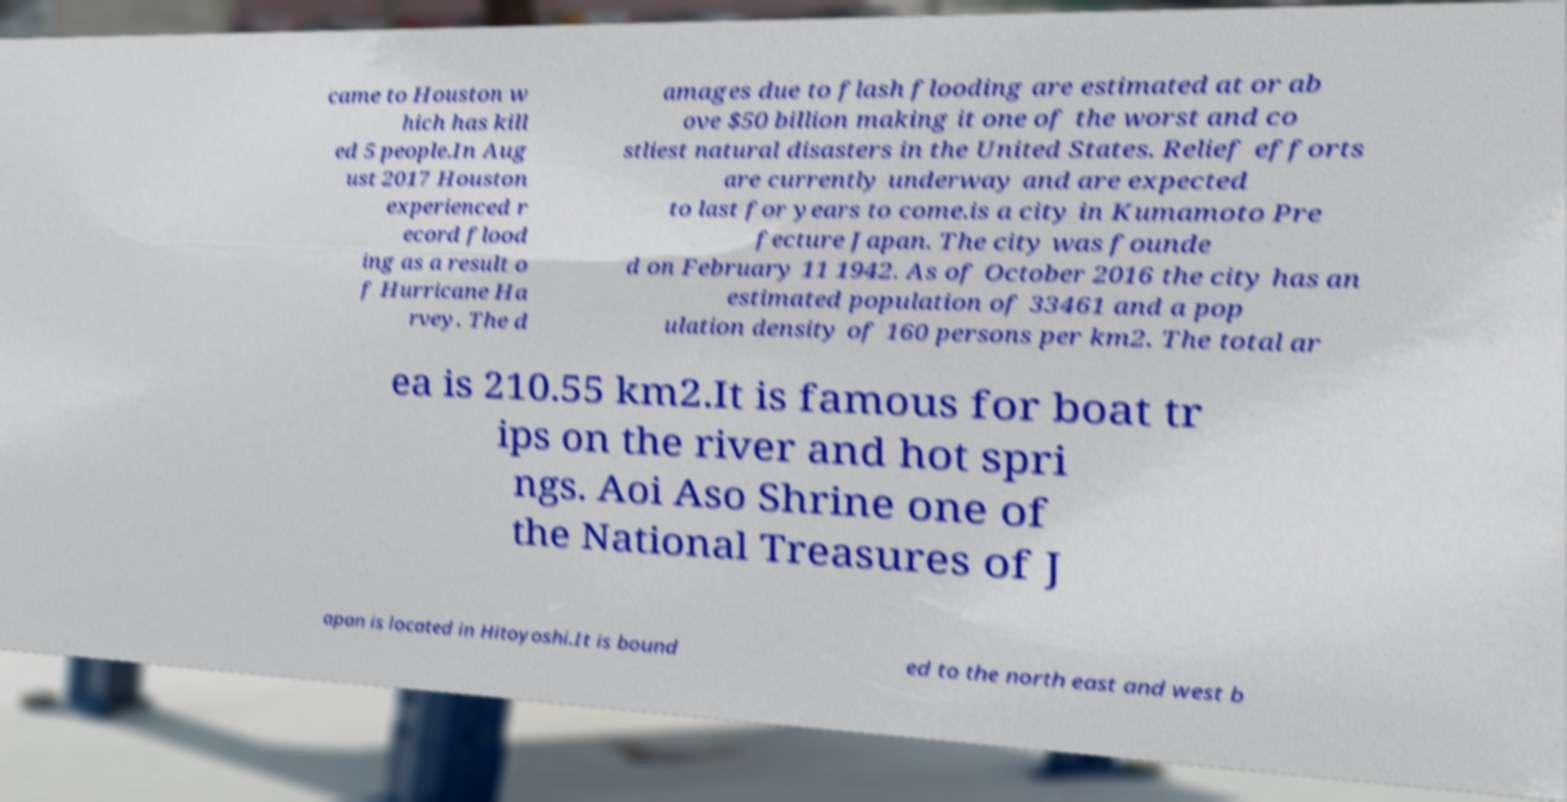Please identify and transcribe the text found in this image. came to Houston w hich has kill ed 5 people.In Aug ust 2017 Houston experienced r ecord flood ing as a result o f Hurricane Ha rvey. The d amages due to flash flooding are estimated at or ab ove $50 billion making it one of the worst and co stliest natural disasters in the United States. Relief efforts are currently underway and are expected to last for years to come.is a city in Kumamoto Pre fecture Japan. The city was founde d on February 11 1942. As of October 2016 the city has an estimated population of 33461 and a pop ulation density of 160 persons per km2. The total ar ea is 210.55 km2.It is famous for boat tr ips on the river and hot spri ngs. Aoi Aso Shrine one of the National Treasures of J apan is located in Hitoyoshi.It is bound ed to the north east and west b 